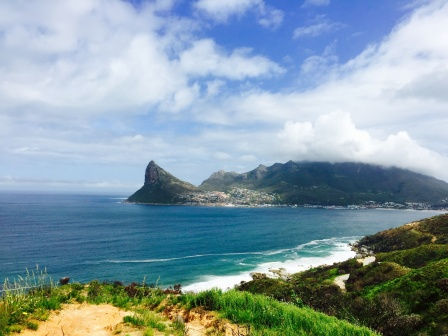Imagine a story taking place in this setting. Once upon a time, in a small coastal town nestled within lush green hills, lived a young girl named Elara. Elara was known for her curiosity and love for exploring the natural beauty surrounding her home. Every morning, she would stroll along the shore, collecting seashells and watching the playful dolphins leap out of the water. Her favorite spot was a secret cove hidden among the rocky coastline, where she felt a deep connection to the ocean's mysteries.

One day, while wandering in her secret cove, Elara discovered an old, weathered chest partially buried in the sand. Intrigued, she dug it out and found it filled with ancient maps, mysterious artifacts, and a journal written in a language she didn't recognize. Determined to uncover the secrets of the chest, Elara embarked on a journey to learn about the origins of the items and the history of her beloved town.

As she delved deeper into her quest, she unraveled tales of legendary sea creatures, long-lost treasures, and the ancient guardians of the coastal lands. Along the way, she met wise elders, adventurous sailors, and kindred spirits who shared her passion for discovery. Through her adventures, Elara learned about the delicate balance between nature and humanity, and the importance of preserving the beauty and history of her home.

Eventually, Elara's journey led her to a hidden underwater cave where she revealed the final piece of the puzzle – a key to understanding the intricate relationship between the ocean's secrets and the thriving coastal town. With this knowledge, she vowed to protect and cherish the environment, becoming a guardian of the coast and an inspiration to future generations of explorers. And so, Elara's story became woven into the fabric of the town's history, a testament to the magic and wonder that lay within the stunning coastal landscape. 